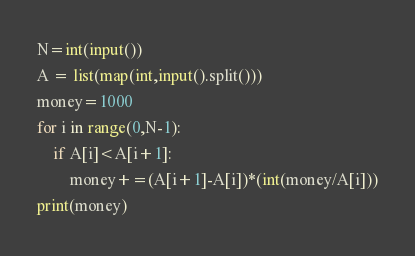Convert code to text. <code><loc_0><loc_0><loc_500><loc_500><_Python_>N=int(input())
A = list(map(int,input().split()))
money=1000
for i in range(0,N-1):
    if A[i]<A[i+1]:
        money+=(A[i+1]-A[i])*(int(money/A[i]))
print(money)
</code> 